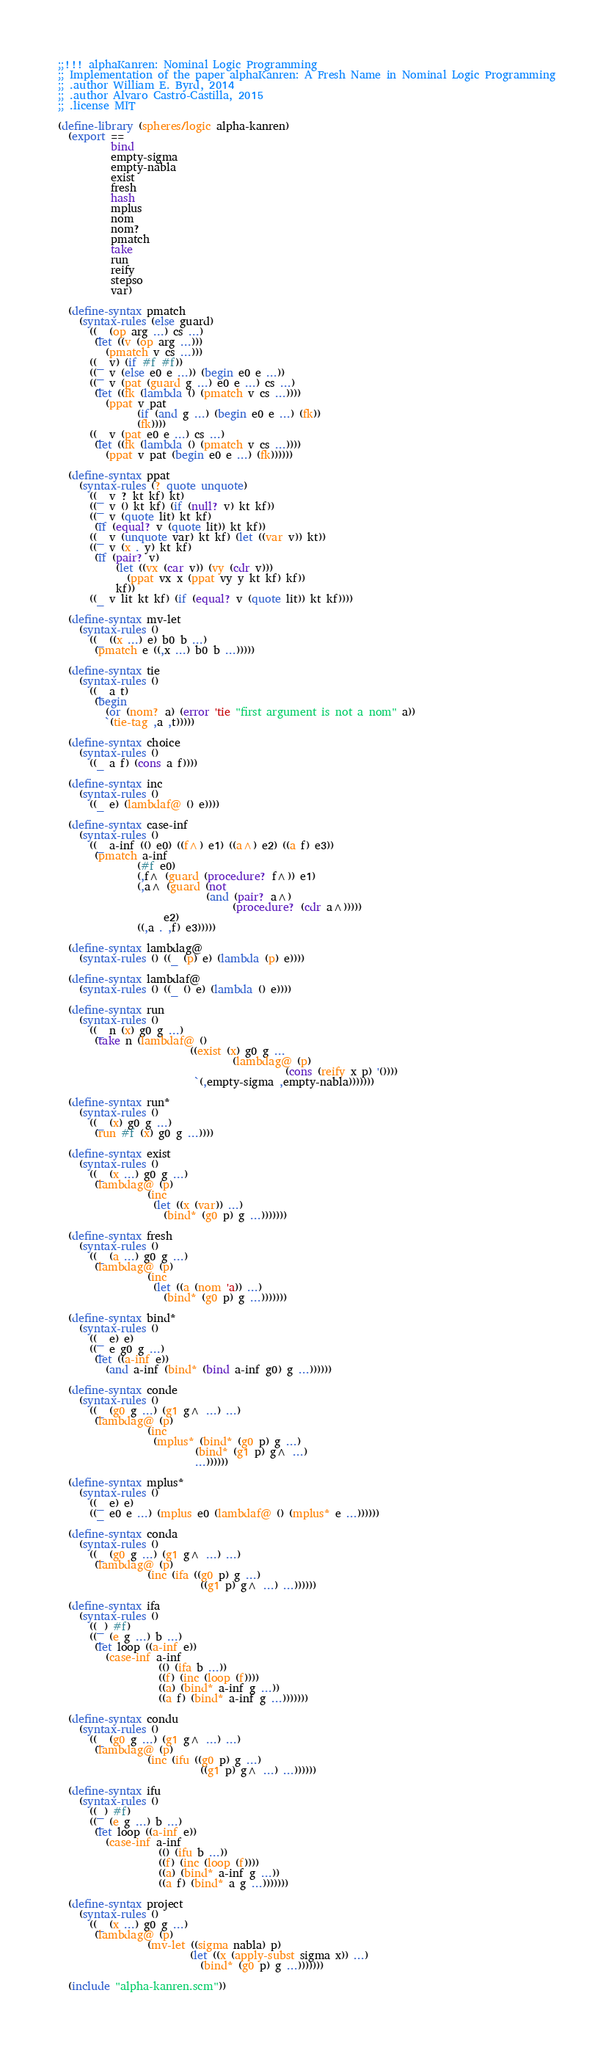Convert code to text. <code><loc_0><loc_0><loc_500><loc_500><_Scheme_>;;!!! alphaKanren: Nominal Logic Programming
;; Implementation of the paper alphaKanren: A Fresh Name in Nominal Logic Programming
;; .author William E. Byrd, 2014
;; .author Alvaro Castro-Castilla, 2015
;; .license MIT

(define-library (spheres/logic alpha-kanren)
  (export ==
          bind
          empty-sigma
          empty-nabla
          exist
          fresh
          hash
          mplus
          nom
          nom?
          pmatch
          take
          run
          reify
          stepso
          var)

  (define-syntax pmatch
    (syntax-rules (else guard)
      ((_ (op arg ...) cs ...)
       (let ((v (op arg ...)))
         (pmatch v cs ...)))
      ((_ v) (if #f #f))
      ((_ v (else e0 e ...)) (begin e0 e ...))
      ((_ v (pat (guard g ...) e0 e ...) cs ...)
       (let ((fk (lambda () (pmatch v cs ...))))
         (ppat v pat
               (if (and g ...) (begin e0 e ...) (fk))
               (fk))))
      ((_ v (pat e0 e ...) cs ...)
       (let ((fk (lambda () (pmatch v cs ...))))
         (ppat v pat (begin e0 e ...) (fk))))))

  (define-syntax ppat
    (syntax-rules (? quote unquote)
      ((_ v ? kt kf) kt)
      ((_ v () kt kf) (if (null? v) kt kf))
      ((_ v (quote lit) kt kf)
       (if (equal? v (quote lit)) kt kf))
      ((_ v (unquote var) kt kf) (let ((var v)) kt))
      ((_ v (x . y) kt kf)
       (if (pair? v)
           (let ((vx (car v)) (vy (cdr v)))
             (ppat vx x (ppat vy y kt kf) kf))
           kf))
      ((_ v lit kt kf) (if (equal? v (quote lit)) kt kf))))

  (define-syntax mv-let
    (syntax-rules ()
      ((_ ((x ...) e) b0 b ...)
       (pmatch e ((,x ...) b0 b ...)))))

  (define-syntax tie
    (syntax-rules ()
      ((_ a t)
       (begin
         (or (nom? a) (error 'tie "first argument is not a nom" a))
         `(tie-tag ,a ,t)))))

  (define-syntax choice
    (syntax-rules ()
      ((_ a f) (cons a f))))

  (define-syntax inc
    (syntax-rules ()
      ((_ e) (lambdaf@ () e))))

  (define-syntax case-inf
    (syntax-rules ()
      ((_ a-inf (() e0) ((f^) e1) ((a^) e2) ((a f) e3))
       (pmatch a-inf
               (#f e0)
               (,f^ (guard (procedure? f^)) e1)
               (,a^ (guard (not
                            (and (pair? a^)
                                 (procedure? (cdr a^)))))
                    e2)
               ((,a . ,f) e3)))))

  (define-syntax lambdag@
    (syntax-rules () ((_ (p) e) (lambda (p) e))))

  (define-syntax lambdaf@
    (syntax-rules () ((_ () e) (lambda () e))))

  (define-syntax run
    (syntax-rules ()
      ((_ n (x) g0 g ...)
       (take n (lambdaf@ ()
                         ((exist (x) g0 g ...
                                 (lambdag@ (p)
                                           (cons (reify x p) '())))
                          `(,empty-sigma ,empty-nabla)))))))

  (define-syntax run*
    (syntax-rules ()
      ((_ (x) g0 g ...)
       (run #f (x) g0 g ...))))

  (define-syntax exist
    (syntax-rules ()
      ((_ (x ...) g0 g ...)
       (lambdag@ (p)
                 (inc
                  (let ((x (var)) ...)
                    (bind* (g0 p) g ...)))))))

  (define-syntax fresh
    (syntax-rules ()
      ((_ (a ...) g0 g ...)
       (lambdag@ (p)
                 (inc
                  (let ((a (nom 'a)) ...)
                    (bind* (g0 p) g ...)))))))

  (define-syntax bind*
    (syntax-rules ()
      ((_ e) e)
      ((_ e g0 g ...)
       (let ((a-inf e))
         (and a-inf (bind* (bind a-inf g0) g ...))))))

  (define-syntax conde
    (syntax-rules ()
      ((_ (g0 g ...) (g1 g^ ...) ...)
       (lambdag@ (p)
                 (inc
                  (mplus* (bind* (g0 p) g ...)
                          (bind* (g1 p) g^ ...)
                          ...))))))

  (define-syntax mplus*
    (syntax-rules ()
      ((_ e) e)
      ((_ e0 e ...) (mplus e0 (lambdaf@ () (mplus* e ...))))))

  (define-syntax conda
    (syntax-rules ()
      ((_ (g0 g ...) (g1 g^ ...) ...)
       (lambdag@ (p)
                 (inc (ifa ((g0 p) g ...)
                           ((g1 p) g^ ...) ...))))))

  (define-syntax ifa
    (syntax-rules ()
      ((_) #f)
      ((_ (e g ...) b ...)
       (let loop ((a-inf e))
         (case-inf a-inf
                   (() (ifa b ...))
                   ((f) (inc (loop (f))))
                   ((a) (bind* a-inf g ...))
                   ((a f) (bind* a-inf g ...)))))))

  (define-syntax condu
    (syntax-rules ()
      ((_ (g0 g ...) (g1 g^ ...) ...)
       (lambdag@ (p)
                 (inc (ifu ((g0 p) g ...)
                           ((g1 p) g^ ...) ...))))))

  (define-syntax ifu
    (syntax-rules ()
      ((_) #f)
      ((_ (e g ...) b ...)
       (let loop ((a-inf e))
         (case-inf a-inf
                   (() (ifu b ...))
                   ((f) (inc (loop (f))))
                   ((a) (bind* a-inf g ...))
                   ((a f) (bind* a g ...)))))))

  (define-syntax project
    (syntax-rules ()
      ((_ (x ...) g0 g ...)
       (lambdag@ (p)
                 (mv-let ((sigma nabla) p)
                         (let ((x (apply-subst sigma x)) ...)
                           (bind* (g0 p) g ...)))))))

  (include "alpha-kanren.scm"))
</code> 